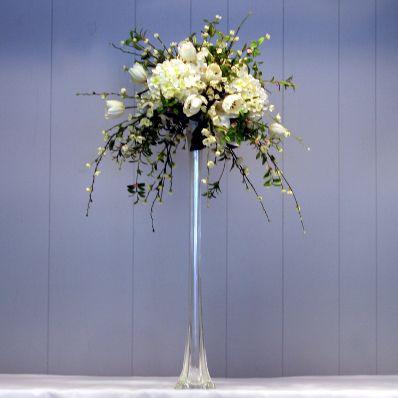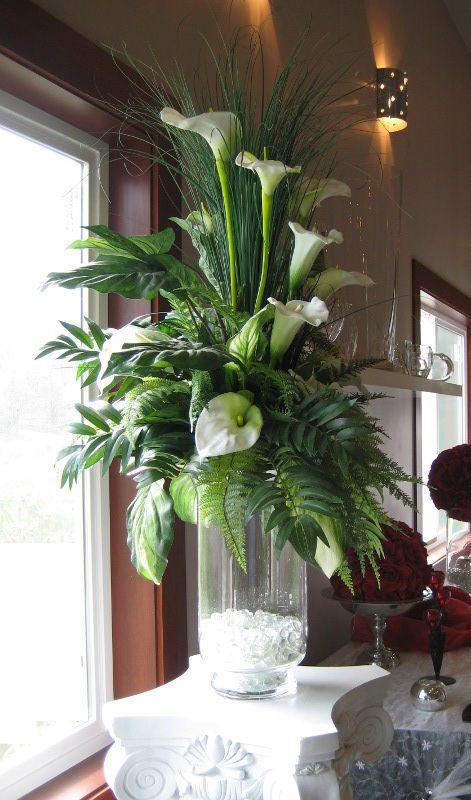The first image is the image on the left, the second image is the image on the right. Given the left and right images, does the statement "There are pink flowers in the vase in the image on the left." hold true? Answer yes or no. No. 